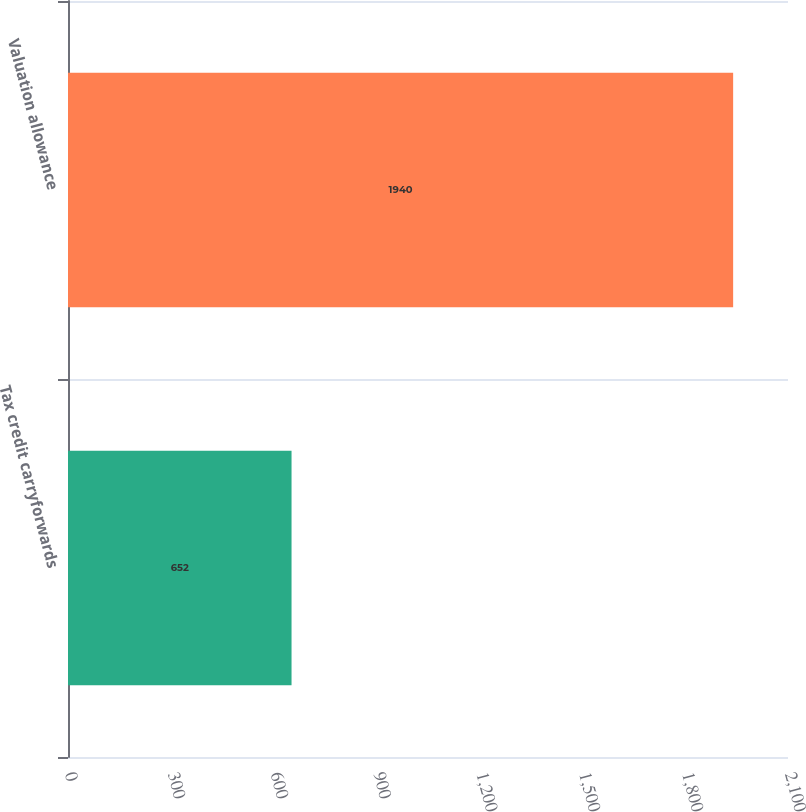<chart> <loc_0><loc_0><loc_500><loc_500><bar_chart><fcel>Tax credit carryforwards<fcel>Valuation allowance<nl><fcel>652<fcel>1940<nl></chart> 